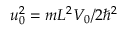Convert formula to latex. <formula><loc_0><loc_0><loc_500><loc_500>u _ { 0 } ^ { 2 } = m L ^ { 2 } V _ { 0 } / 2 \hbar { ^ } { 2 }</formula> 